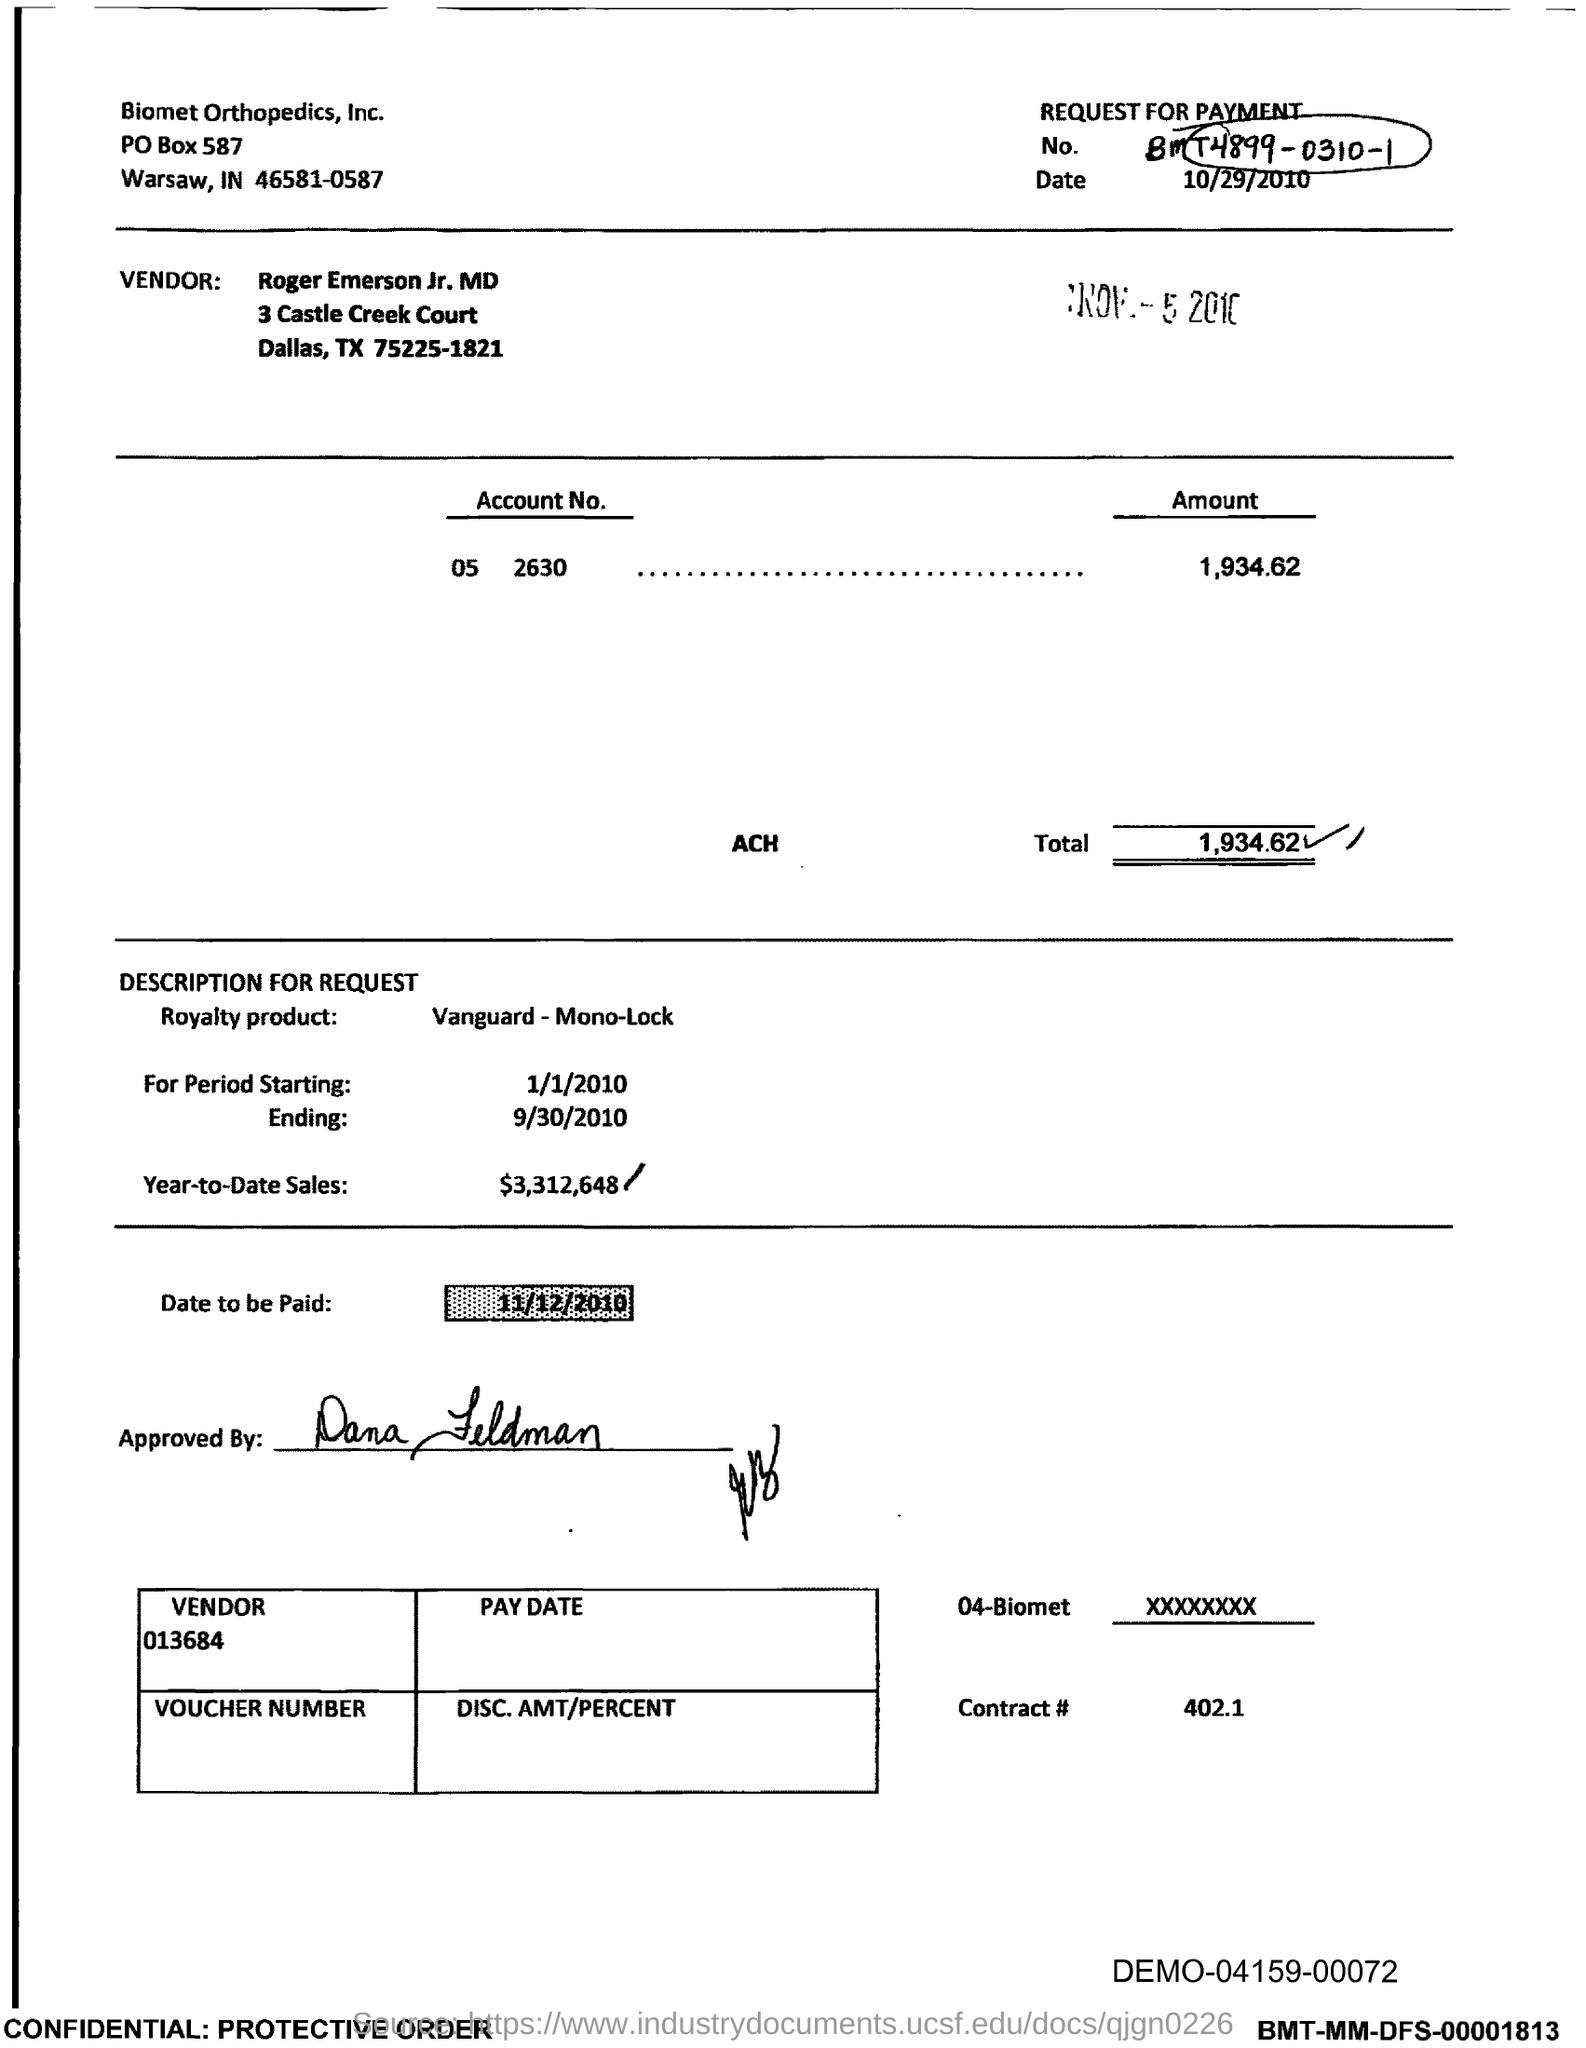List a handful of essential elements in this visual. The request for payment as stated in the document is "BMT4899-0310-1... Biomet Orthopedics, Inc. is the company mentioned in the header of the document, The vendor mentioned in the document is Roger Emerson Jr., MD. The total amount indicated in the document is 1,934.62. The contract number provided in the document is 402.1. 